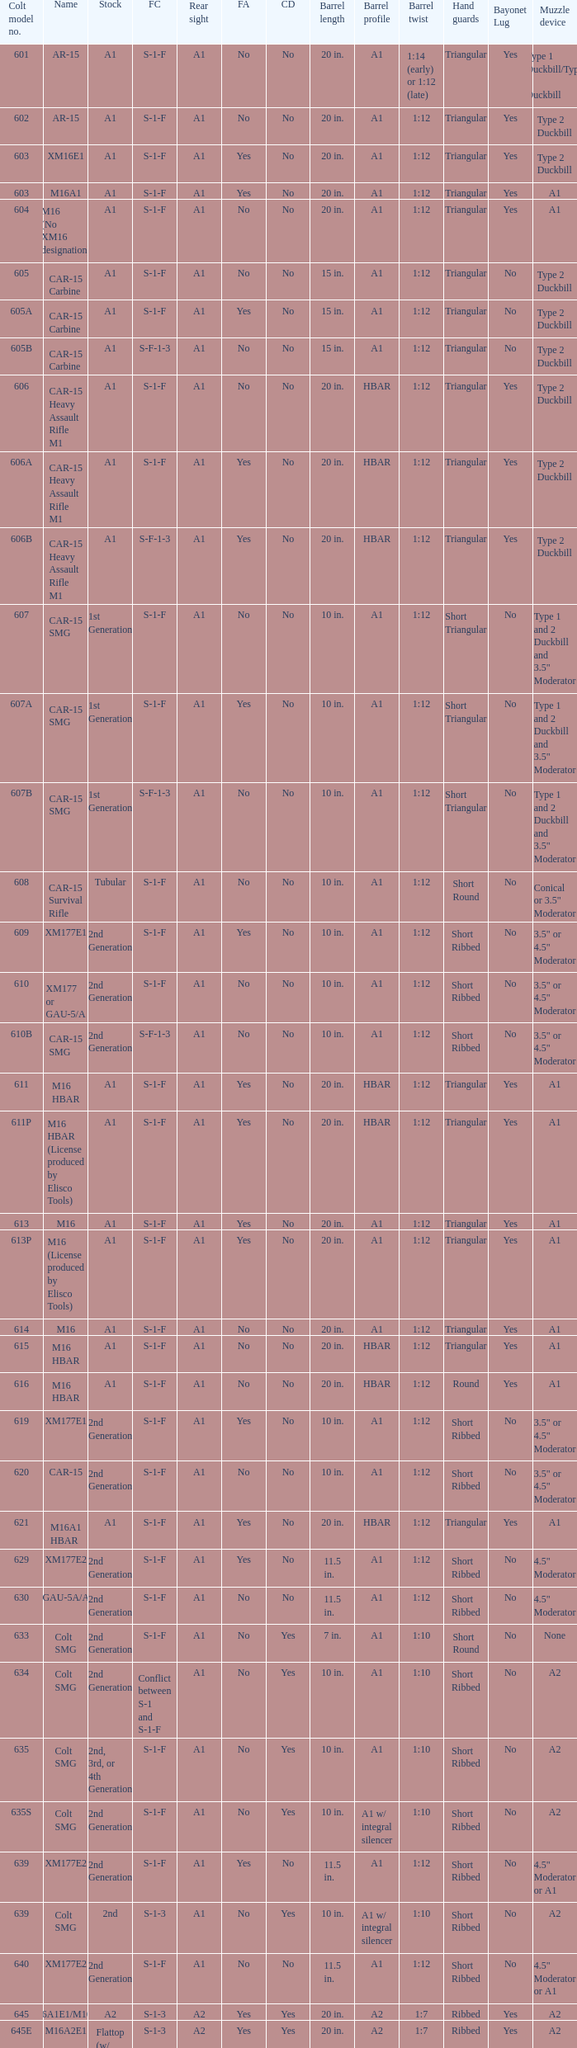What is the rear sight in the Cole model no. 735? A1 or A2. 